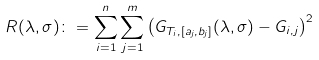Convert formula to latex. <formula><loc_0><loc_0><loc_500><loc_500>R ( \lambda , \sigma ) \colon = \sum _ { i = 1 } ^ { n } \sum _ { j = 1 } ^ { m } \left ( G _ { T _ { i } , [ a _ { j } , b _ { j } ] } ( \lambda , \sigma ) - G _ { i , j } \right ) ^ { 2 }</formula> 